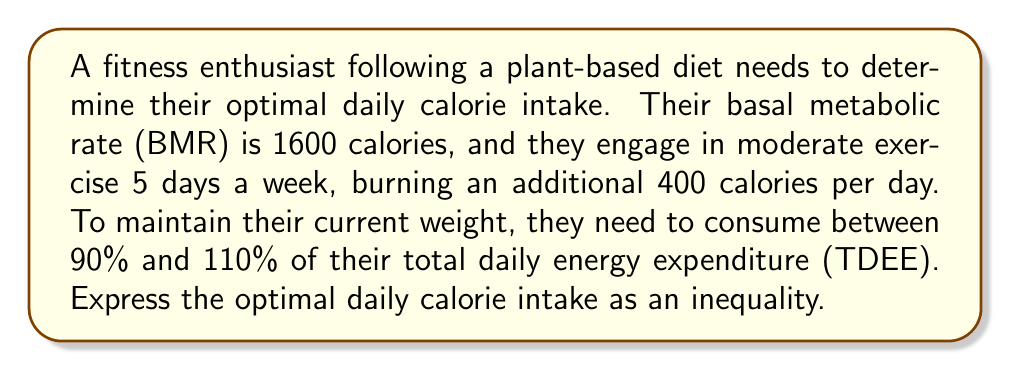Help me with this question. 1. Calculate the Total Daily Energy Expenditure (TDEE):
   BMR + Daily exercise calories = TDEE
   $1600 + 400 = 2000$ calories

2. Calculate the lower bound (90% of TDEE):
   $0.90 \times 2000 = 1800$ calories

3. Calculate the upper bound (110% of TDEE):
   $1.10 \times 2000 = 2200$ calories

4. Express the optimal daily calorie intake as an inequality:
   Let $x$ be the daily calorie intake.
   The inequality can be written as:
   $1800 \leq x \leq 2200$

5. This inequality represents the range of calories that will allow the fitness enthusiast to maintain their current weight while following a plant-based diet and engaging in moderate exercise 5 days a week.
Answer: $1800 \leq x \leq 2200$ 